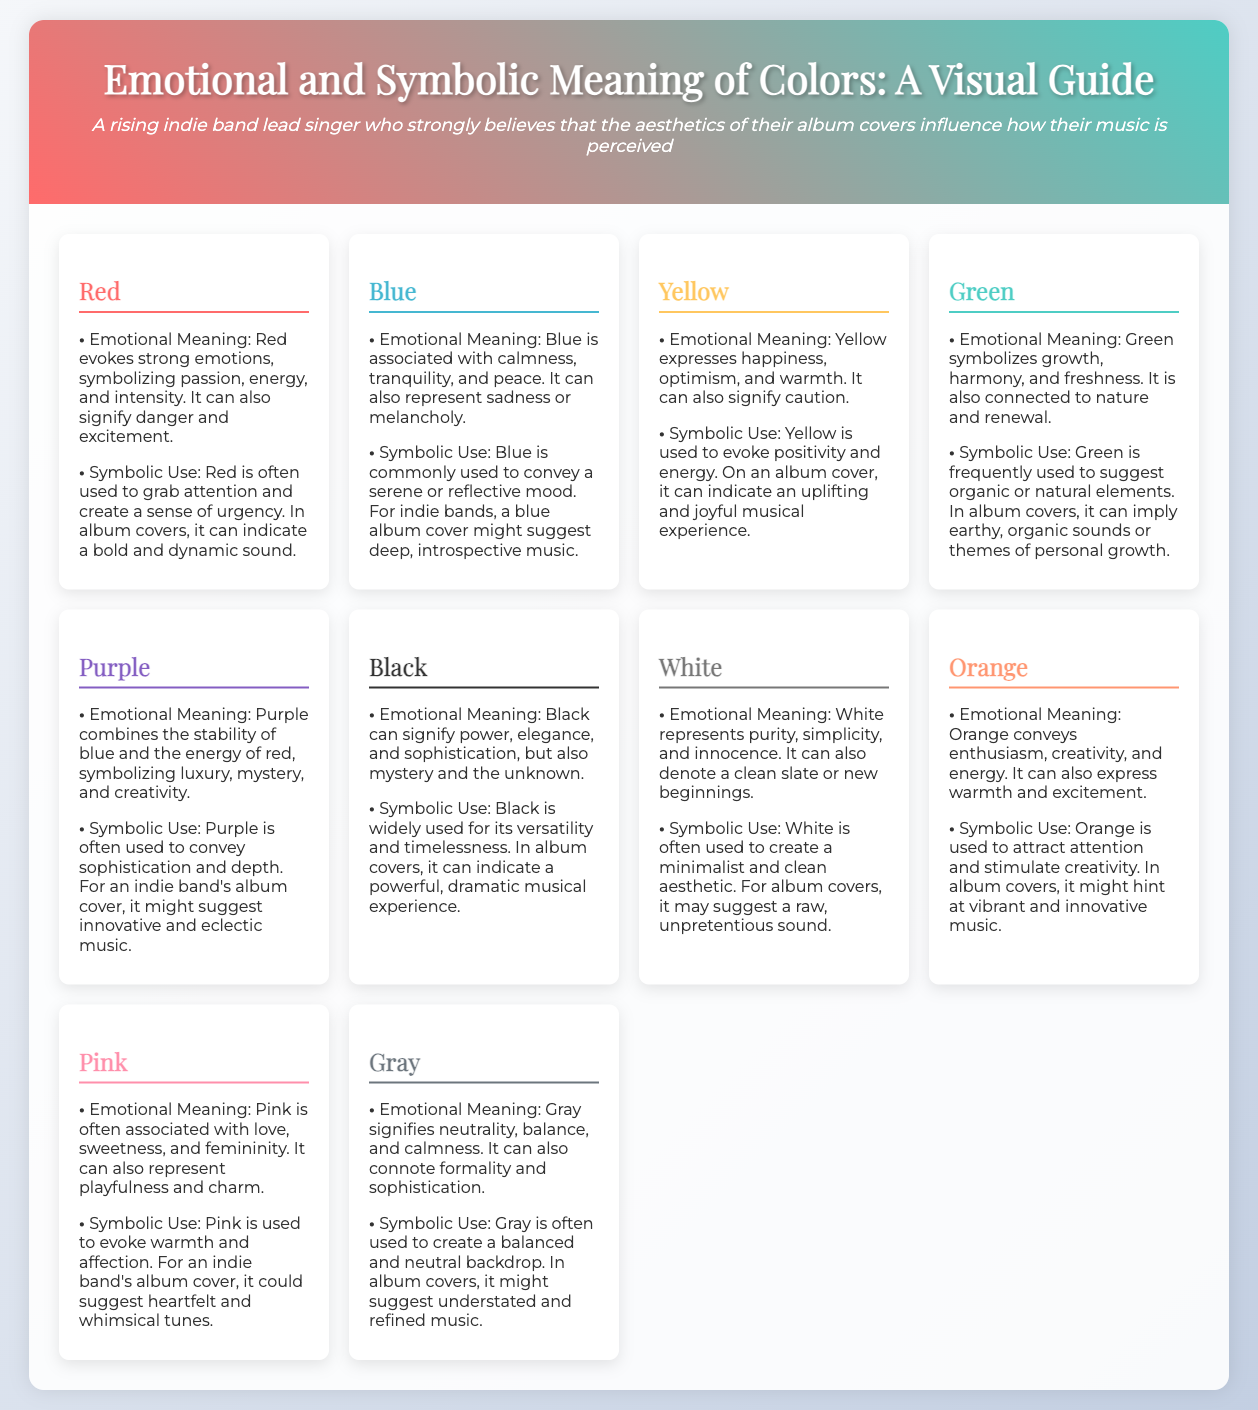What does the color red symbolize? The color red symbolizes passion, energy, and intensity, while also signifying danger and excitement.
Answer: Passion, energy, intensity What emotional meaning is associated with blue? Blue is associated with calmness, tranquility, and peace, and can also represent sadness or melancholy.
Answer: Calmness, tranquility, peace How does yellow make people feel? Yellow expresses happiness, optimism, and warmth, and can also signify caution.
Answer: Happiness, optimism, warmth Which color is linked to personal growth? Green symbolizes growth, harmony, and freshness, and is associated with nature and renewal.
Answer: Green What emotional meaning does black convey? Black signifies power, elegance, sophistication, mystery, and the unknown.
Answer: Power, elegance, sophistication Why might an indie band's album cover use orange? Orange is used to attract attention and stimulate creativity, hinting at vibrant and innovative music.
Answer: Vibrant and innovative music Which color suggests a minimalist aesthetic? White is often used to create a minimalist and clean aesthetic.
Answer: White What does purple represent in terms of creativity? Purple symbolizes luxury, mystery, and creativity, reflecting sophistication and depth.
Answer: Luxury, mystery, creativity What versatile color can indicate a dramatic musical experience? Black is widely used for its versatility and timelessness, indicating a powerful, dramatic musical experience.
Answer: Black 